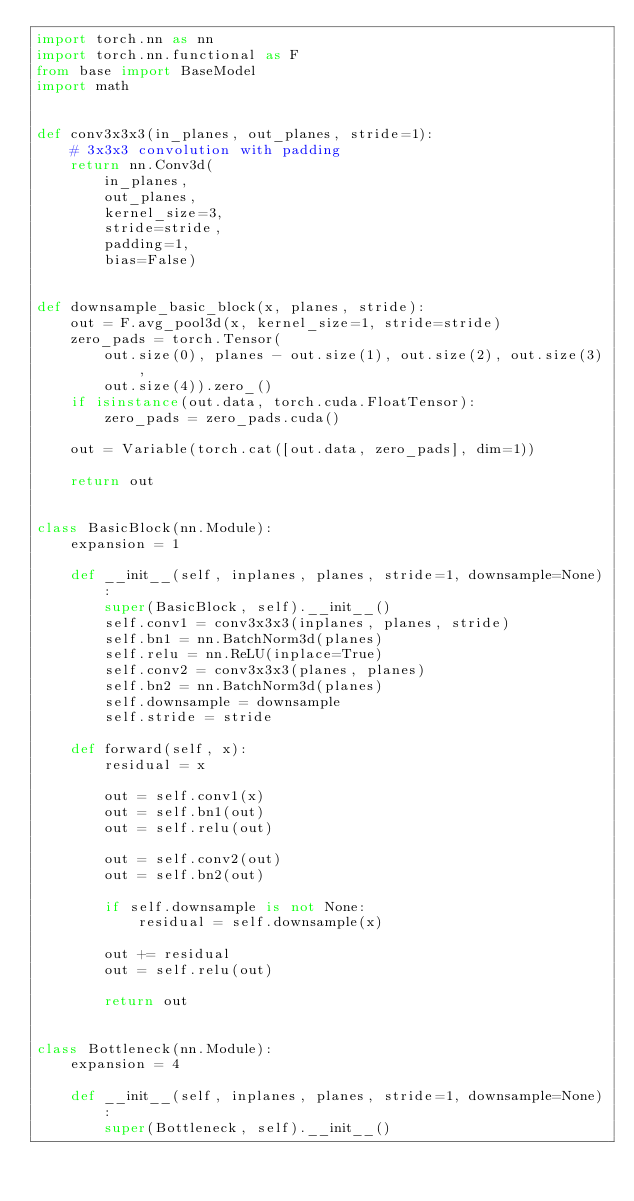<code> <loc_0><loc_0><loc_500><loc_500><_Python_>import torch.nn as nn
import torch.nn.functional as F
from base import BaseModel
import math


def conv3x3x3(in_planes, out_planes, stride=1):
    # 3x3x3 convolution with padding
    return nn.Conv3d(
        in_planes,
        out_planes,
        kernel_size=3,
        stride=stride,
        padding=1,
        bias=False)


def downsample_basic_block(x, planes, stride):
    out = F.avg_pool3d(x, kernel_size=1, stride=stride)
    zero_pads = torch.Tensor(
        out.size(0), planes - out.size(1), out.size(2), out.size(3),
        out.size(4)).zero_()
    if isinstance(out.data, torch.cuda.FloatTensor):
        zero_pads = zero_pads.cuda()

    out = Variable(torch.cat([out.data, zero_pads], dim=1))

    return out


class BasicBlock(nn.Module):
    expansion = 1

    def __init__(self, inplanes, planes, stride=1, downsample=None):
        super(BasicBlock, self).__init__()
        self.conv1 = conv3x3x3(inplanes, planes, stride)
        self.bn1 = nn.BatchNorm3d(planes)
        self.relu = nn.ReLU(inplace=True)
        self.conv2 = conv3x3x3(planes, planes)
        self.bn2 = nn.BatchNorm3d(planes)
        self.downsample = downsample
        self.stride = stride

    def forward(self, x):
        residual = x

        out = self.conv1(x)
        out = self.bn1(out)
        out = self.relu(out)

        out = self.conv2(out)
        out = self.bn2(out)

        if self.downsample is not None:
            residual = self.downsample(x)

        out += residual
        out = self.relu(out)

        return out


class Bottleneck(nn.Module):
    expansion = 4

    def __init__(self, inplanes, planes, stride=1, downsample=None):
        super(Bottleneck, self).__init__()</code> 